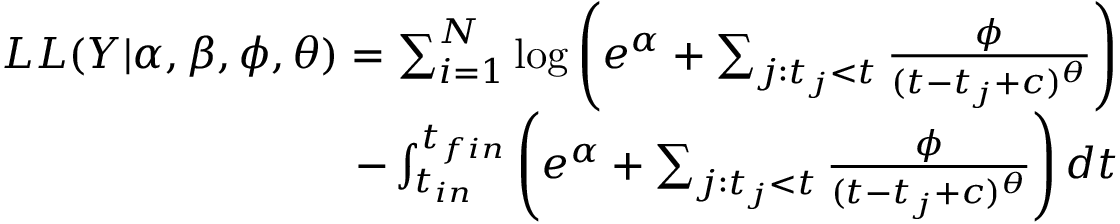<formula> <loc_0><loc_0><loc_500><loc_500>\begin{array} { r } { L L ( Y | \alpha , \beta , \phi , \theta ) = \sum _ { i = 1 } ^ { N } \log \left ( e ^ { \alpha } + \sum _ { j \colon t _ { j } < t } \frac { \phi } { ( t - t _ { j } + c ) ^ { \theta } } \right ) } \\ { - \int _ { t _ { i n } } ^ { t _ { f i n } } \left ( e ^ { \alpha } + \sum _ { j \colon t _ { j } < t } \frac { \phi } { ( t - t _ { j } + c ) ^ { \theta } } \right ) d t } \end{array}</formula> 